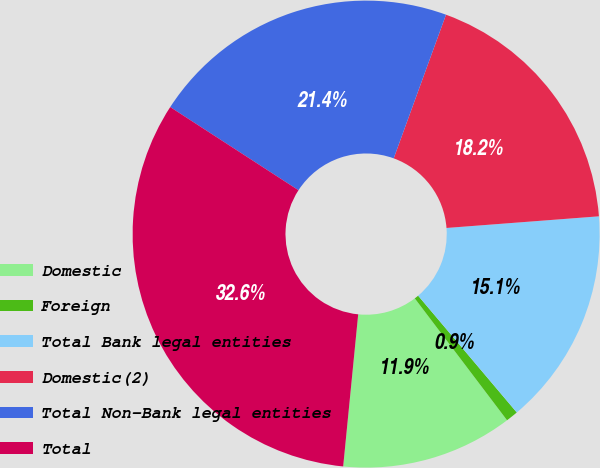Convert chart. <chart><loc_0><loc_0><loc_500><loc_500><pie_chart><fcel>Domestic<fcel>Foreign<fcel>Total Bank legal entities<fcel>Domestic(2)<fcel>Total Non-Bank legal entities<fcel>Total<nl><fcel>11.88%<fcel>0.85%<fcel>15.05%<fcel>18.23%<fcel>21.4%<fcel>32.59%<nl></chart> 